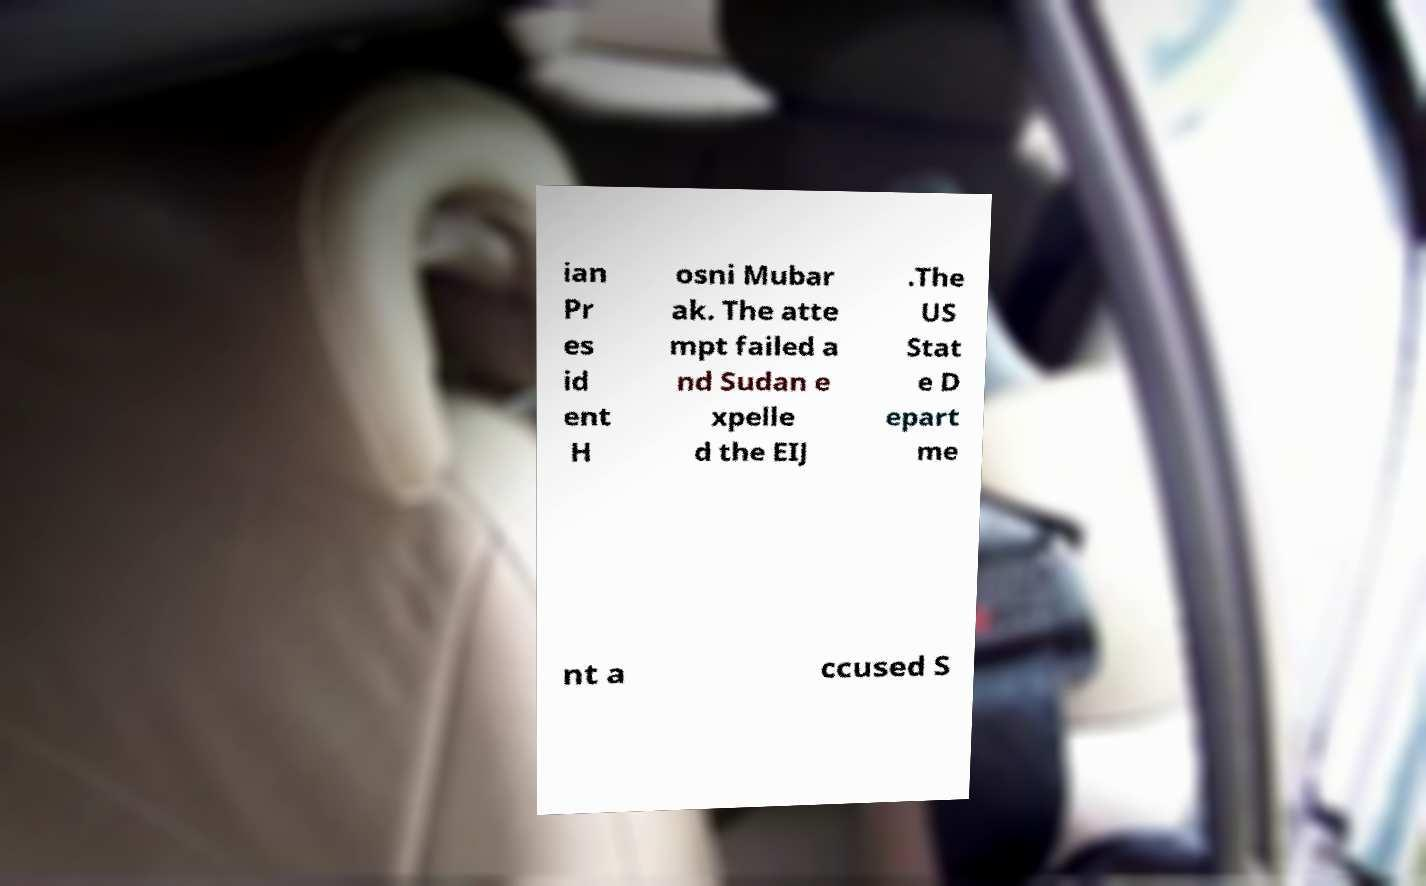I need the written content from this picture converted into text. Can you do that? ian Pr es id ent H osni Mubar ak. The atte mpt failed a nd Sudan e xpelle d the EIJ .The US Stat e D epart me nt a ccused S 